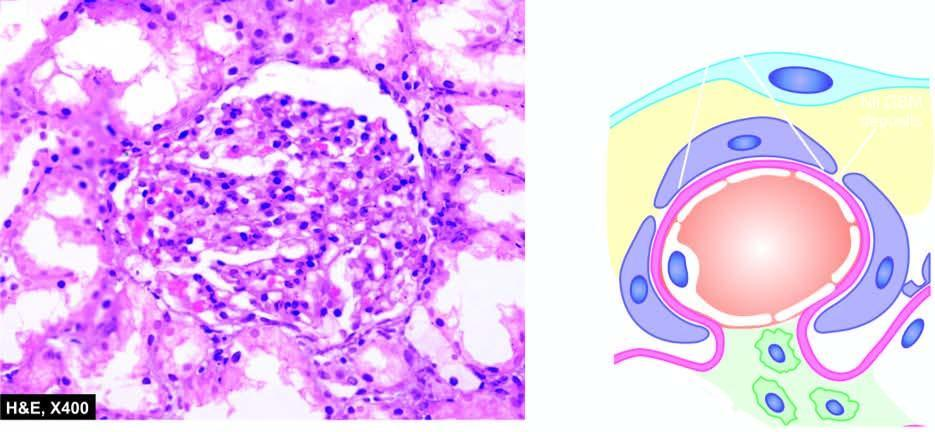re there no deposits?
Answer the question using a single word or phrase. Yes 